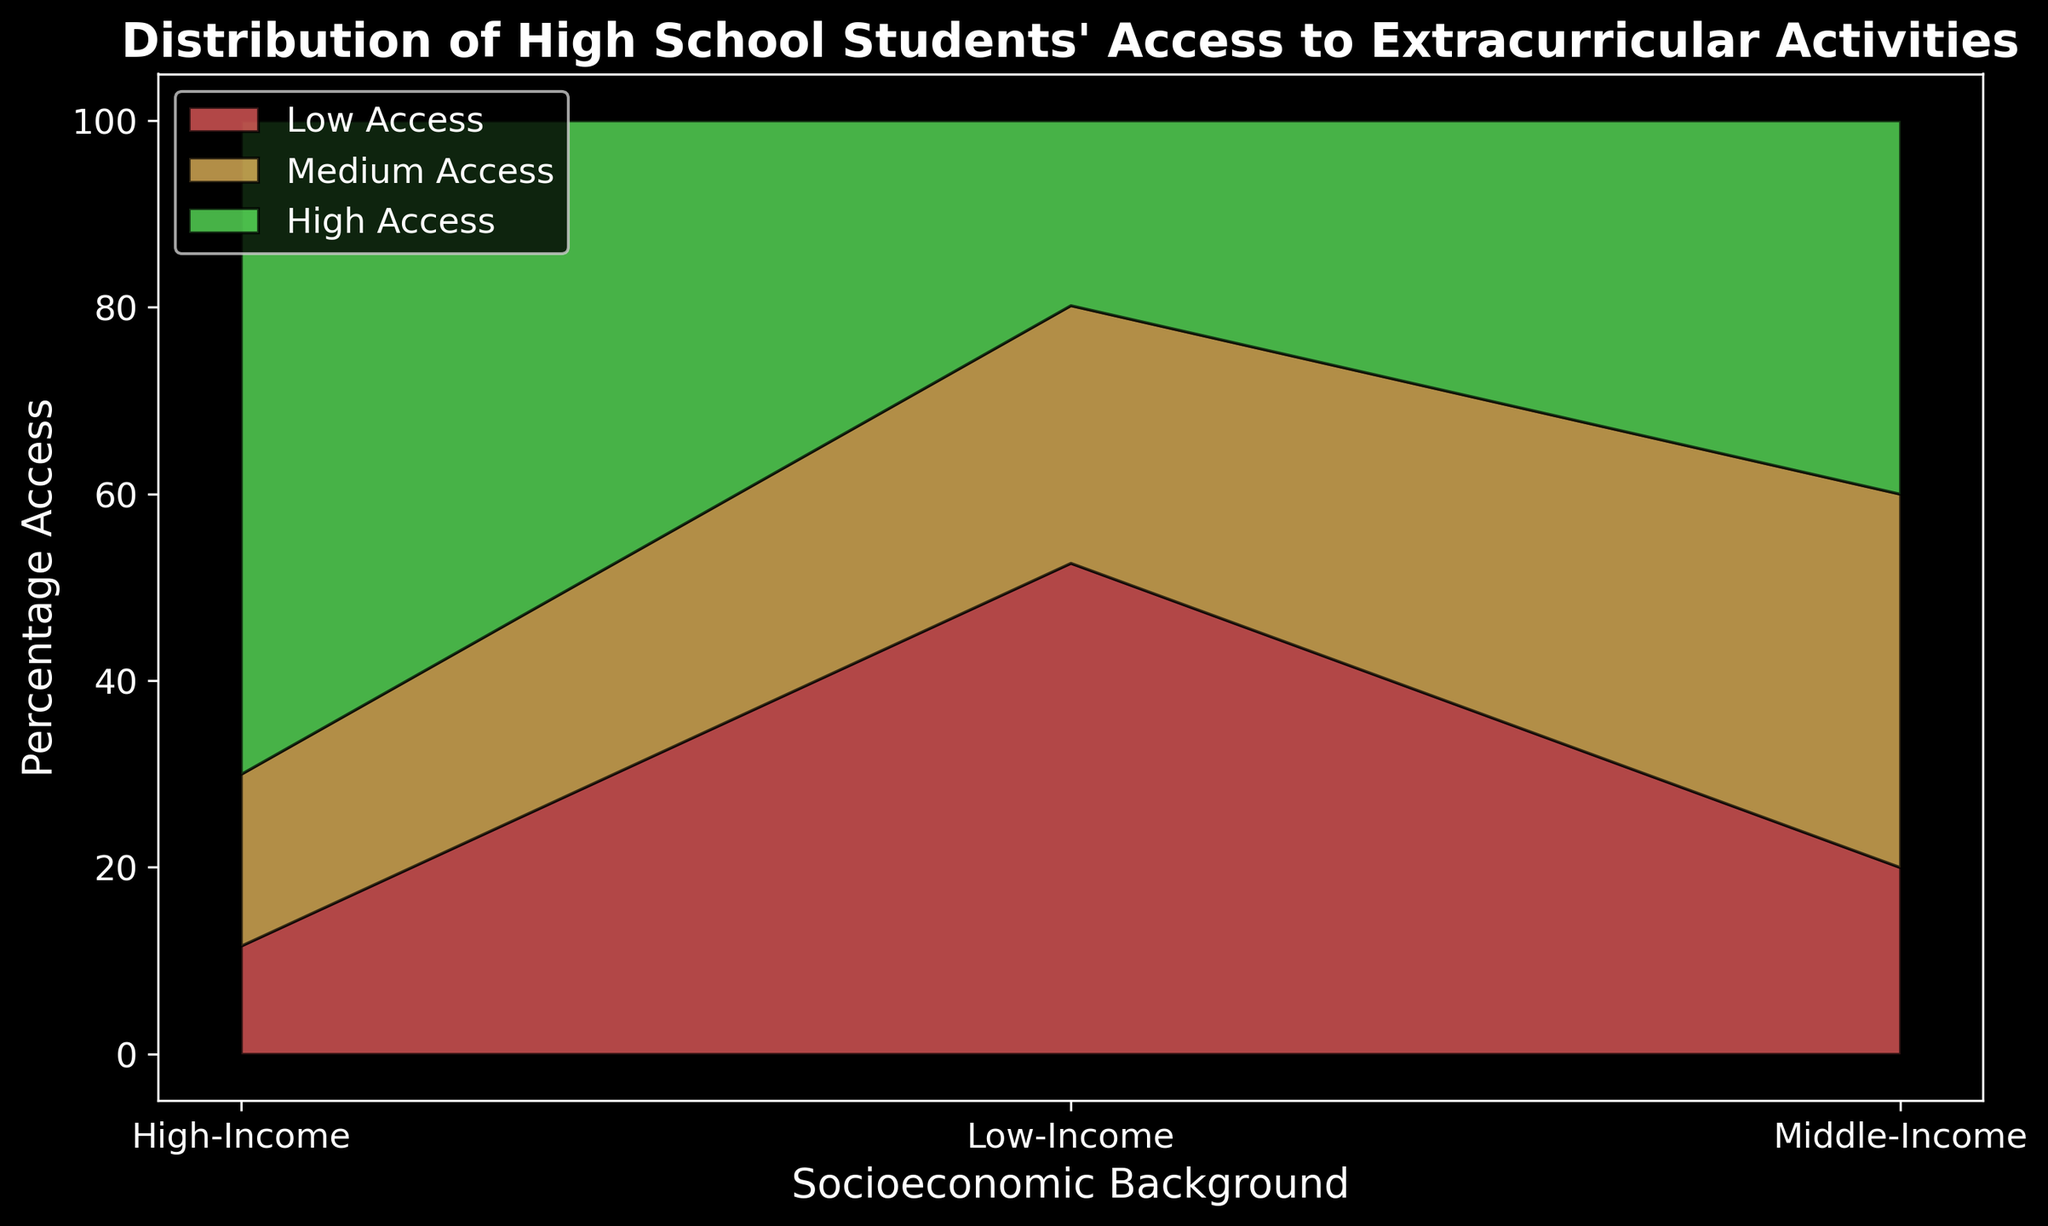What percentage of high-income students have high access to extracurricular activities? Look at the 'High-Income' segment, then observe the green area representing 'High Access' on the y-axis. The value is 70%.
Answer: 70% Which socioeconomic group has the highest percentage of students with low access to extracurricular activities? Compare the red areas for low access across all three socioeconomic groups. The 'Low-Income' group has the largest red area, indicating the highest percentage of low access.
Answer: Low-Income What is the combined percentage of middle-income students with medium and high access to extracurricular activities? Look at the values for 'Medium Access' and 'High Access' in the 'Middle-Income' category. Sum these values: 40% + 40% = 80%.
Answer: 80% Which group shows a larger variability in the percentage of low access across different instances? Compare the variations in the red areas across different instances for each group. The 'Low-Income' group shows the widest range between individual data points, indicating larger variability.
Answer: Low-Income Which socioeconomic group has the smallest percentage of students with medium access to extracurricular activities? Compare the orange areas for medium access across all three socioeconomic groups. The 'High-Income' group has the smallest orange area, representing the lowest percentage of medium access, which is 18%.
Answer: High-Income 